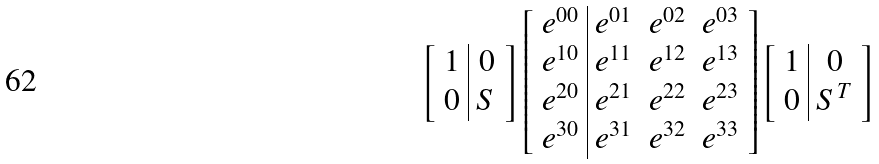<formula> <loc_0><loc_0><loc_500><loc_500>\left [ \begin{array} { c | c } 1 & 0 \\ 0 & S \end{array} \right ] \left [ \begin{array} { c | c c c } e ^ { 0 0 } & e ^ { 0 1 } & e ^ { 0 2 } & e ^ { 0 3 } \\ e ^ { 1 0 } & e ^ { 1 1 } & e ^ { 1 2 } & e ^ { 1 3 } \\ e ^ { 2 0 } & e ^ { 2 1 } & e ^ { 2 2 } & e ^ { 2 3 } \\ e ^ { 3 0 } & e ^ { 3 1 } & e ^ { 3 2 } & e ^ { 3 3 } \\ \end{array} \right ] \left [ \begin{array} { c | c } 1 & 0 \\ 0 & S ^ { T } \end{array} \right ]</formula> 